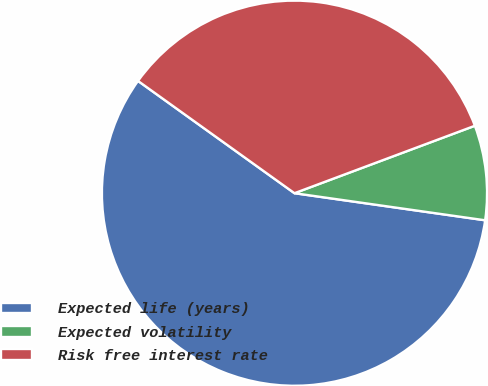<chart> <loc_0><loc_0><loc_500><loc_500><pie_chart><fcel>Expected life (years)<fcel>Expected volatility<fcel>Risk free interest rate<nl><fcel>57.66%<fcel>7.94%<fcel>34.4%<nl></chart> 